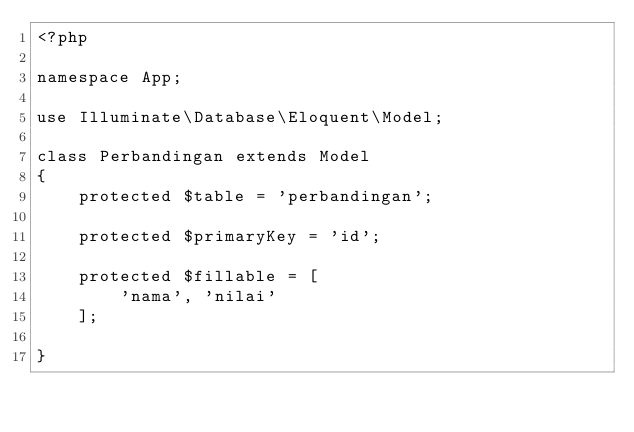Convert code to text. <code><loc_0><loc_0><loc_500><loc_500><_PHP_><?php

namespace App;

use Illuminate\Database\Eloquent\Model;

class Perbandingan extends Model
{
    protected $table = 'perbandingan';

    protected $primaryKey = 'id';

    protected $fillable = [
        'nama', 'nilai'
    ];

}
</code> 